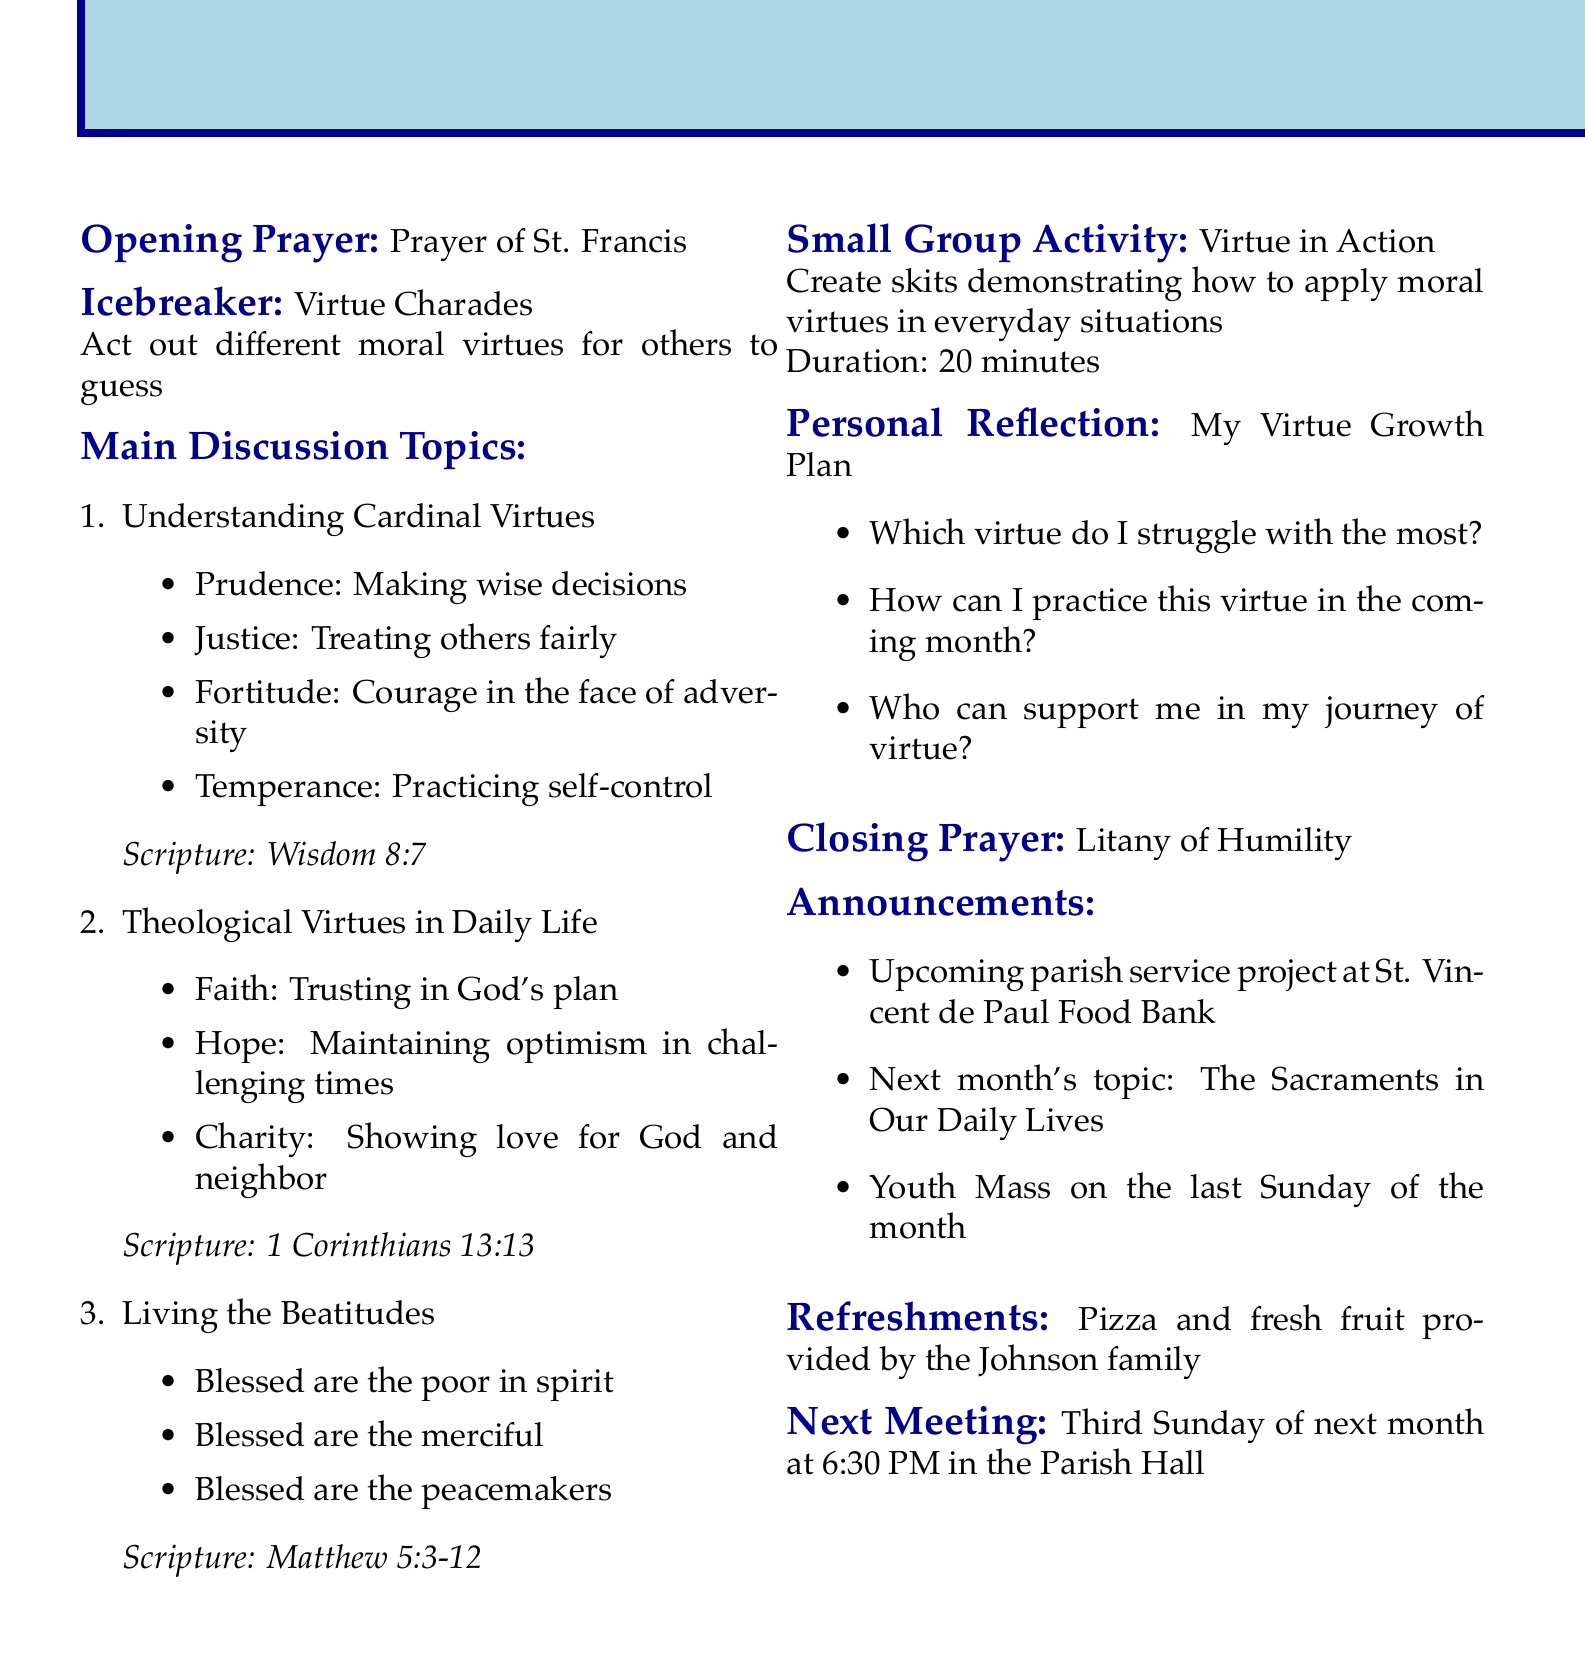What is the title of the meeting? The title of the meeting is stated at the beginning of the document.
Answer: St. Mary's Youth Group - Exploring Moral Virtues What is the opening prayer? The document specifies the opening prayer used in the meeting agenda.
Answer: Prayer of St. Francis How long is the small group activity "Virtue in Action"? The duration of the small group activity is provided in the description.
Answer: 20 minutes What are the theological virtues mentioned? The document lists the theological virtues discussed during the meeting.
Answer: Faith, Hope, Charity Which topic includes "Blessed are the merciful"? This topic is one of the main discussion topics and includes specific phrases from the Beatitudes.
Answer: Living the Beatitudes What is the next meeting date? The document specifies when the next meeting will occur.
Answer: Third Sunday of next month at 6:30 PM What will be served for refreshments? The document mentions the refreshments provided for the meeting.
Answer: Pizza and fresh fruit What activity is planned as an icebreaker? The icebreaker activity is outlined in the agenda.
Answer: Virtue Charades What scripture reference is associated with the cardinal virtues? Each main discussion topic includes a corresponding scripture reference.
Answer: Wisdom 8:7 